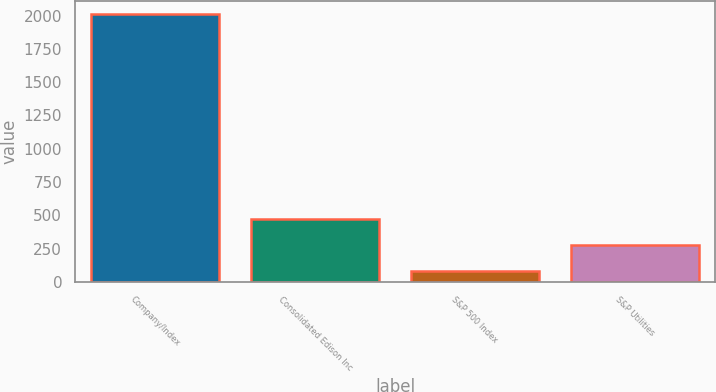<chart> <loc_0><loc_0><loc_500><loc_500><bar_chart><fcel>Company/Index<fcel>Consolidated Edison Inc<fcel>S&P 500 Index<fcel>S&P Utilities<nl><fcel>2009<fcel>469.05<fcel>84.05<fcel>276.55<nl></chart> 